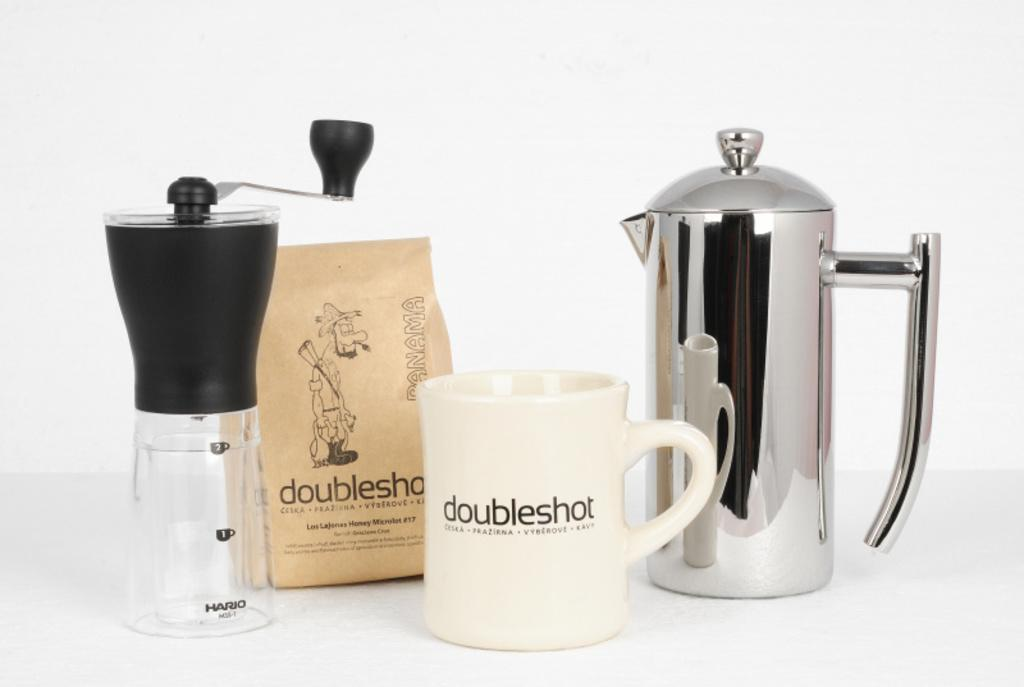<image>
Summarize the visual content of the image. A number of coffee supplies from Doubleshot with a white background. 